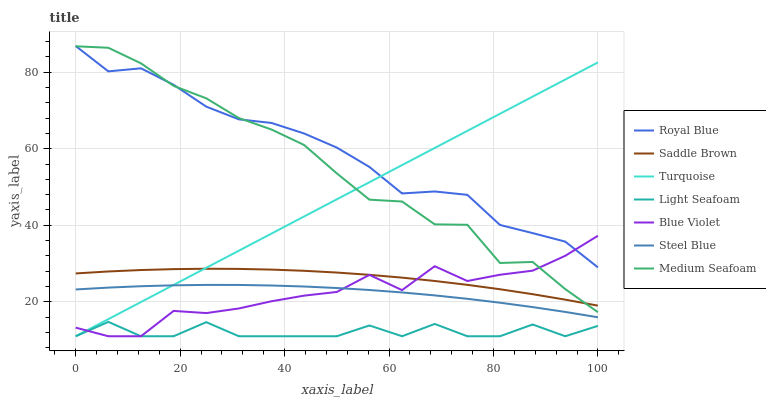Does Light Seafoam have the minimum area under the curve?
Answer yes or no. Yes. Does Royal Blue have the maximum area under the curve?
Answer yes or no. Yes. Does Steel Blue have the minimum area under the curve?
Answer yes or no. No. Does Steel Blue have the maximum area under the curve?
Answer yes or no. No. Is Turquoise the smoothest?
Answer yes or no. Yes. Is Light Seafoam the roughest?
Answer yes or no. Yes. Is Steel Blue the smoothest?
Answer yes or no. No. Is Steel Blue the roughest?
Answer yes or no. No. Does Turquoise have the lowest value?
Answer yes or no. Yes. Does Steel Blue have the lowest value?
Answer yes or no. No. Does Royal Blue have the highest value?
Answer yes or no. Yes. Does Steel Blue have the highest value?
Answer yes or no. No. Is Light Seafoam less than Medium Seafoam?
Answer yes or no. Yes. Is Royal Blue greater than Light Seafoam?
Answer yes or no. Yes. Does Royal Blue intersect Medium Seafoam?
Answer yes or no. Yes. Is Royal Blue less than Medium Seafoam?
Answer yes or no. No. Is Royal Blue greater than Medium Seafoam?
Answer yes or no. No. Does Light Seafoam intersect Medium Seafoam?
Answer yes or no. No. 